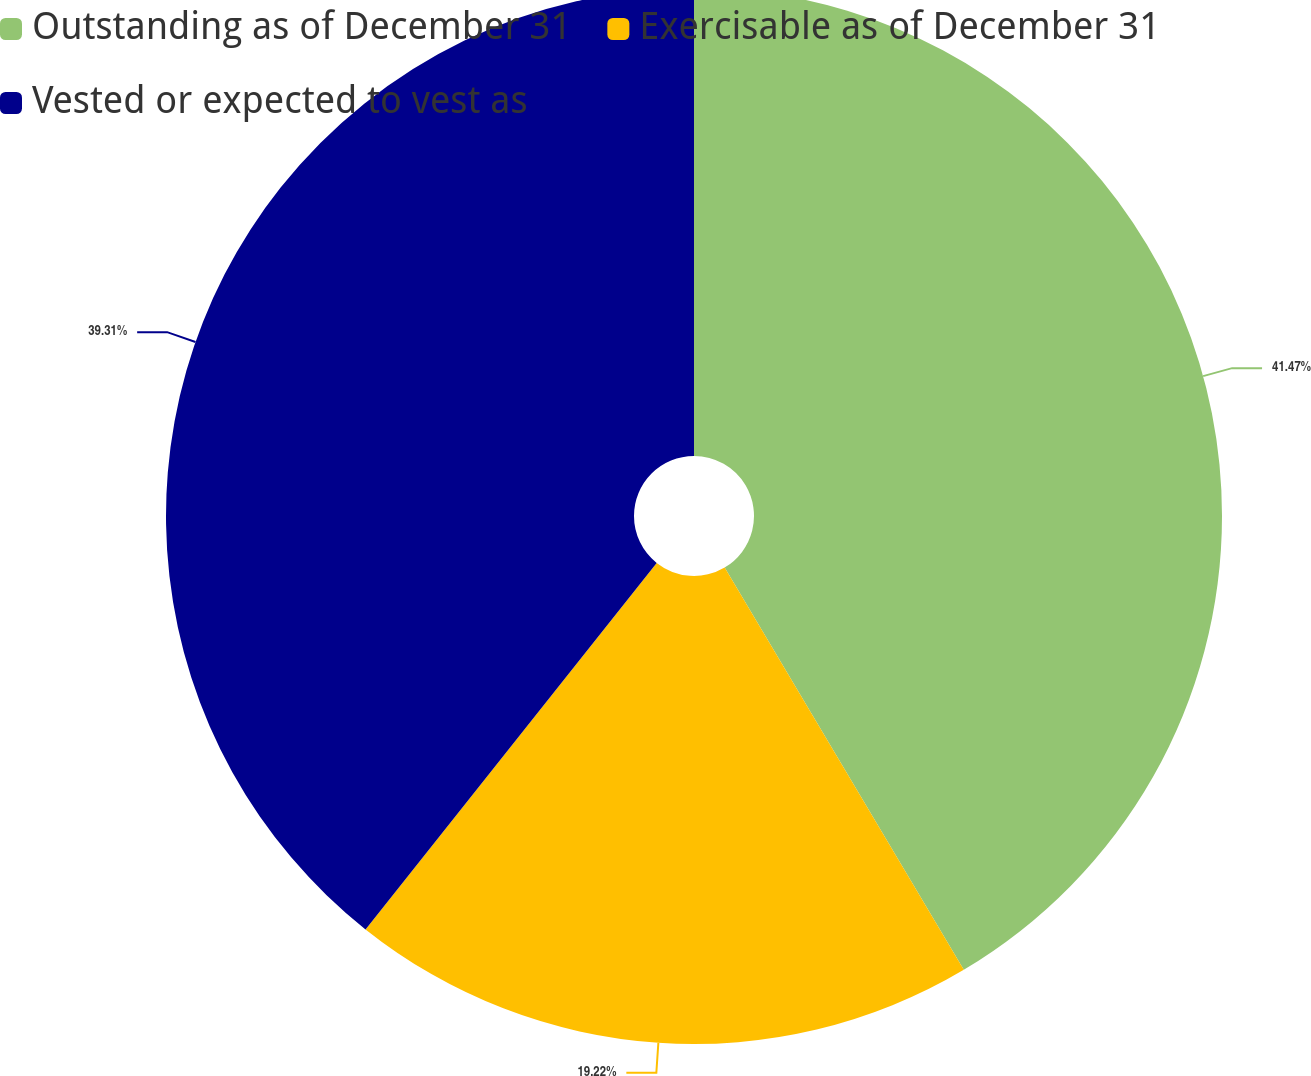<chart> <loc_0><loc_0><loc_500><loc_500><pie_chart><fcel>Outstanding as of December 31<fcel>Exercisable as of December 31<fcel>Vested or expected to vest as<nl><fcel>41.46%<fcel>19.22%<fcel>39.31%<nl></chart> 